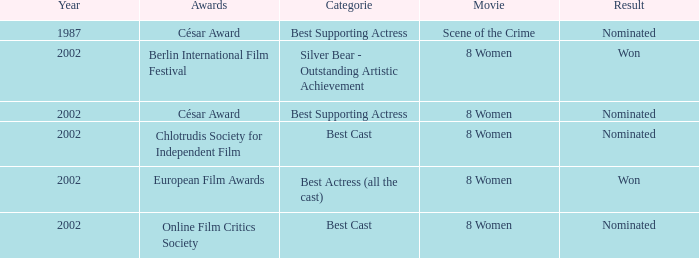What was the result at the Berlin International Film Festival in a year greater than 1987? Won. 